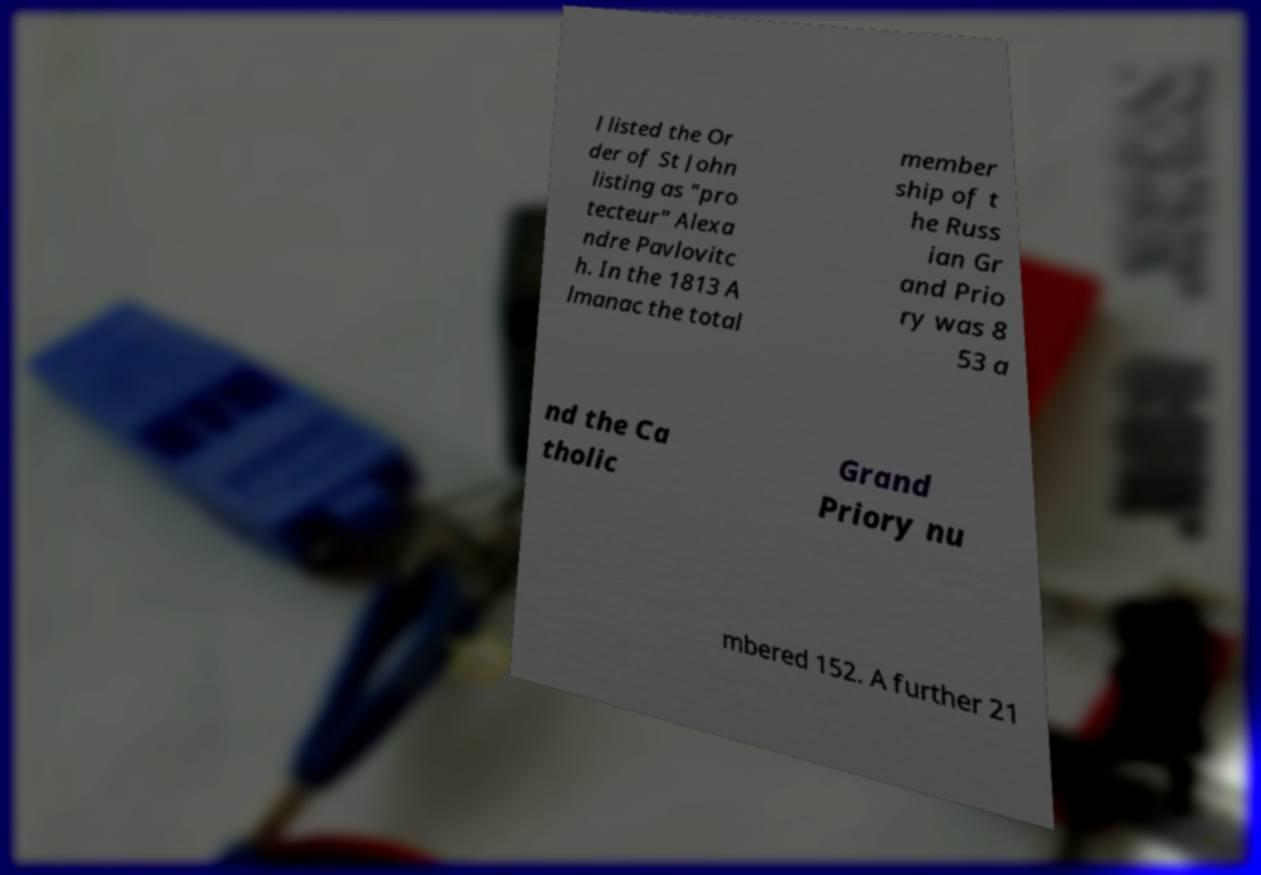For documentation purposes, I need the text within this image transcribed. Could you provide that? l listed the Or der of St John listing as "pro tecteur" Alexa ndre Pavlovitc h. In the 1813 A lmanac the total member ship of t he Russ ian Gr and Prio ry was 8 53 a nd the Ca tholic Grand Priory nu mbered 152. A further 21 